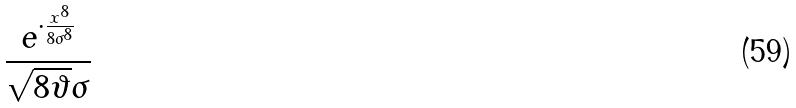Convert formula to latex. <formula><loc_0><loc_0><loc_500><loc_500>\frac { e ^ { \cdot \frac { x ^ { 8 } } { 8 \sigma ^ { 8 } } } } { \sqrt { 8 \vartheta } \sigma }</formula> 